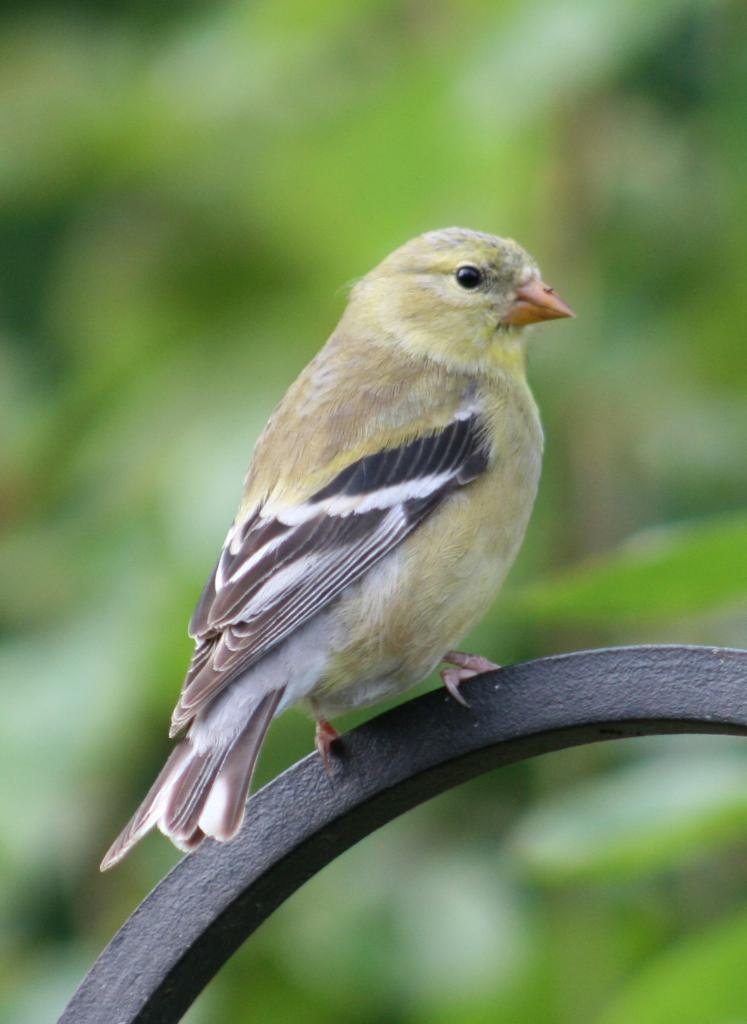What type of animal is in the image? There is a bird in the image. Can you describe the colors of the bird? The bird has orange, black, white, yellow, and ash colors. What is the bird sitting on in the image? The bird is on a black colored object. How would you describe the background of the image? The background of the image is blurry and has a green color. Can you see a nest made of bones in the image? There is no nest made of bones present in the image. What type of brick is used to build the bird's home in the image? There is no brick or bird's home visible in the image. 